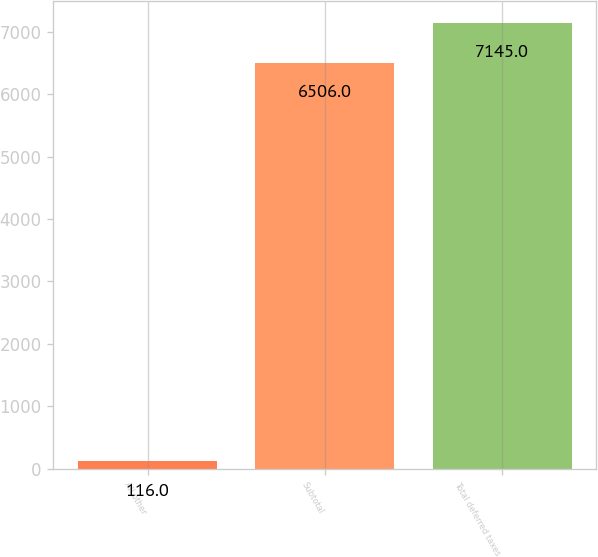Convert chart to OTSL. <chart><loc_0><loc_0><loc_500><loc_500><bar_chart><fcel>All other<fcel>Subtotal<fcel>Total deferred taxes<nl><fcel>116<fcel>6506<fcel>7145<nl></chart> 